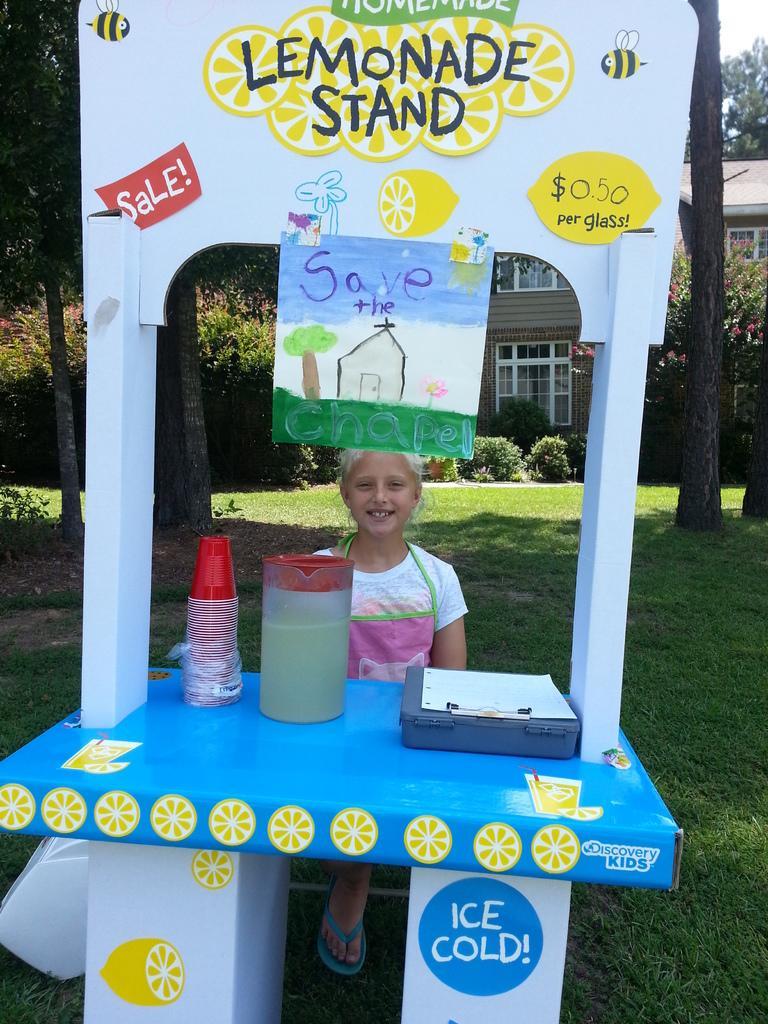How would you summarize this image in a sentence or two? In this image we can see a person near the stall, a poster attached to the stall and there are few glasses, a jug with juice, a box and a paper on the table and there are few trees and a building in the background. 